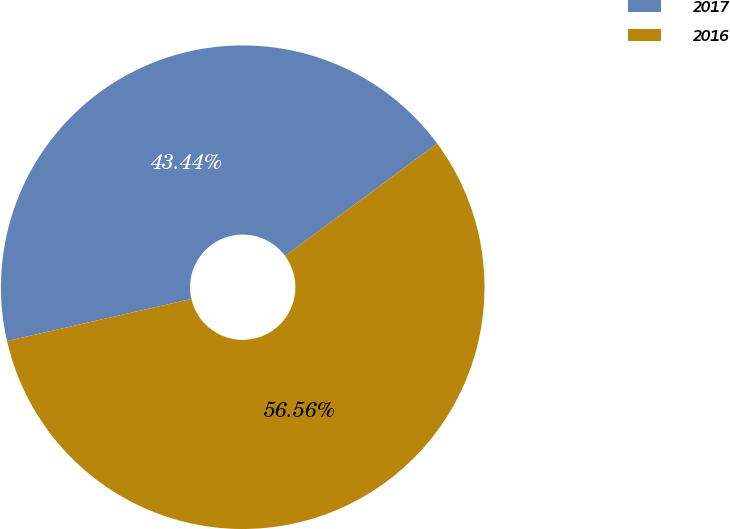<chart> <loc_0><loc_0><loc_500><loc_500><pie_chart><fcel>2017<fcel>2016<nl><fcel>43.44%<fcel>56.56%<nl></chart> 